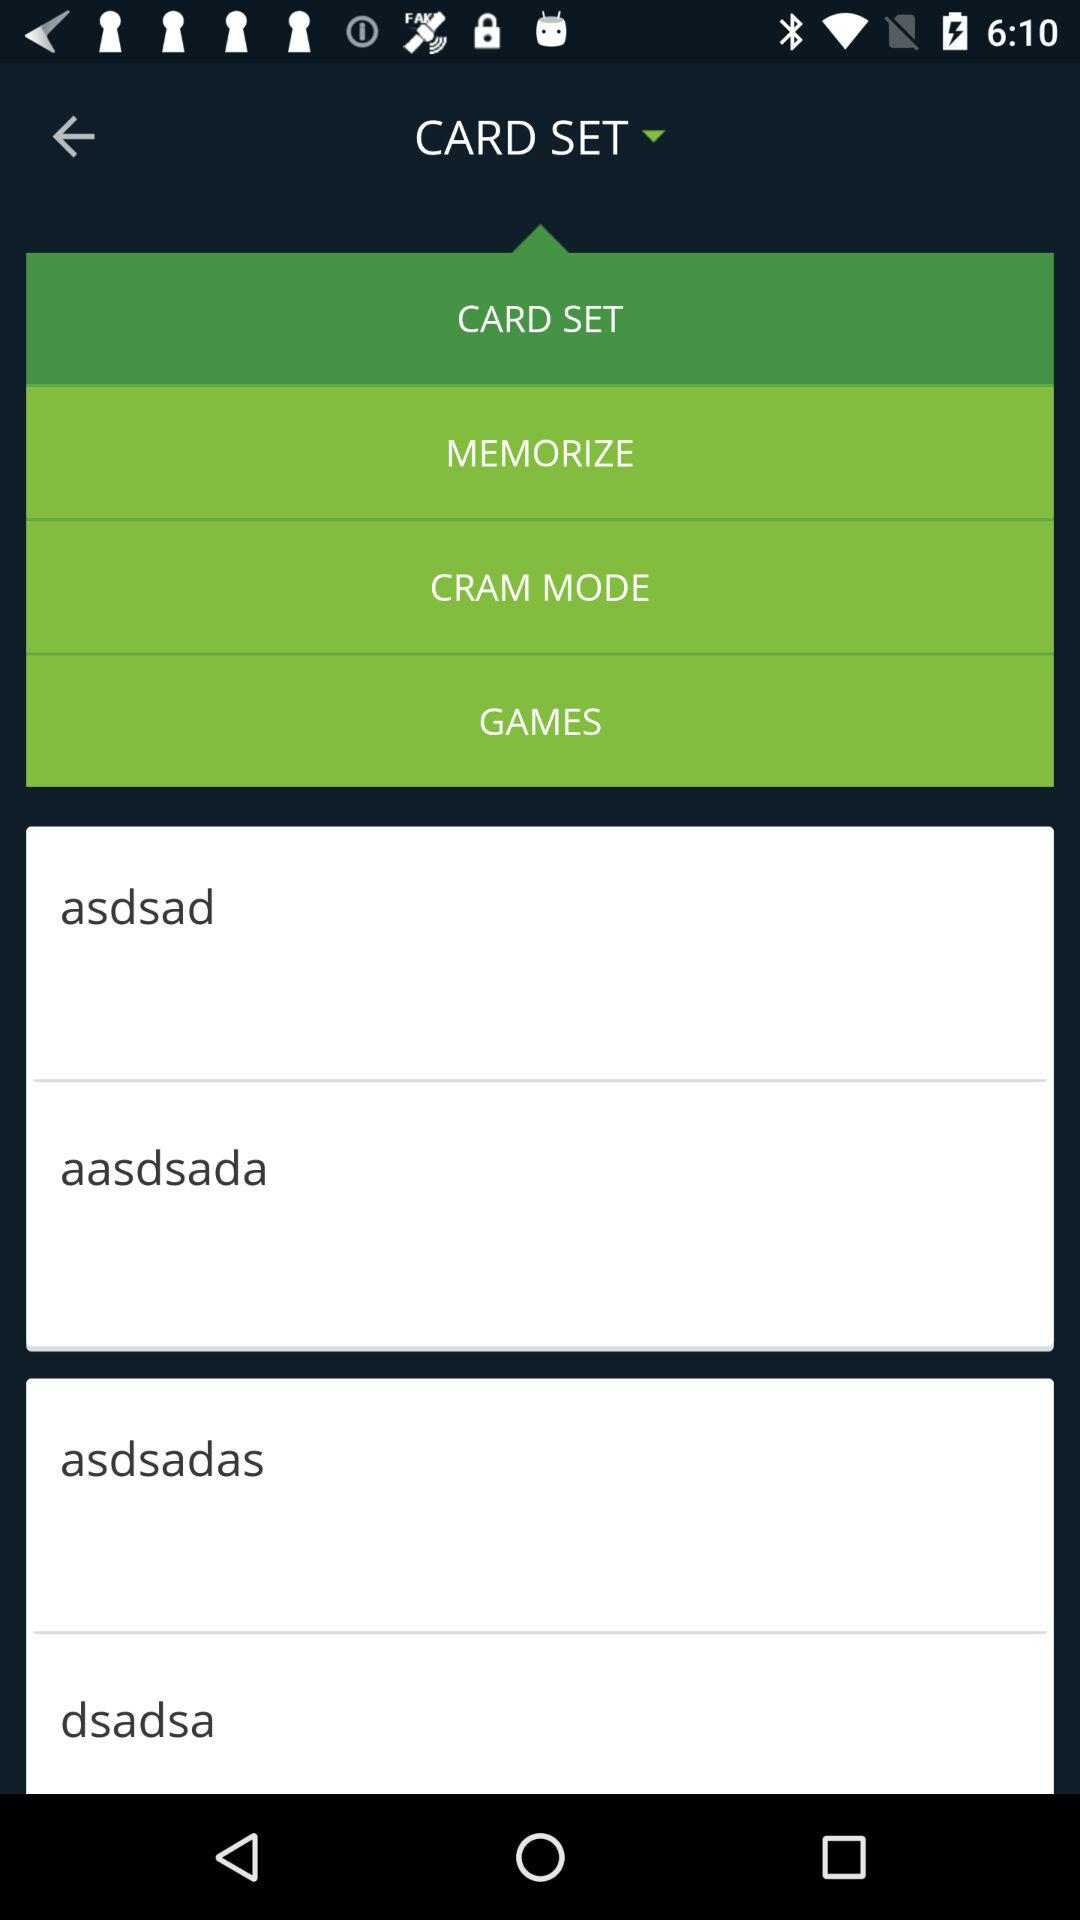How many text items are on the screen?
Answer the question using a single word or phrase. 4 